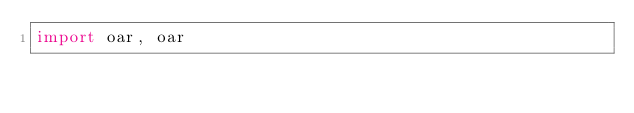Convert code to text. <code><loc_0><loc_0><loc_500><loc_500><_Python_>import oar, oar</code> 